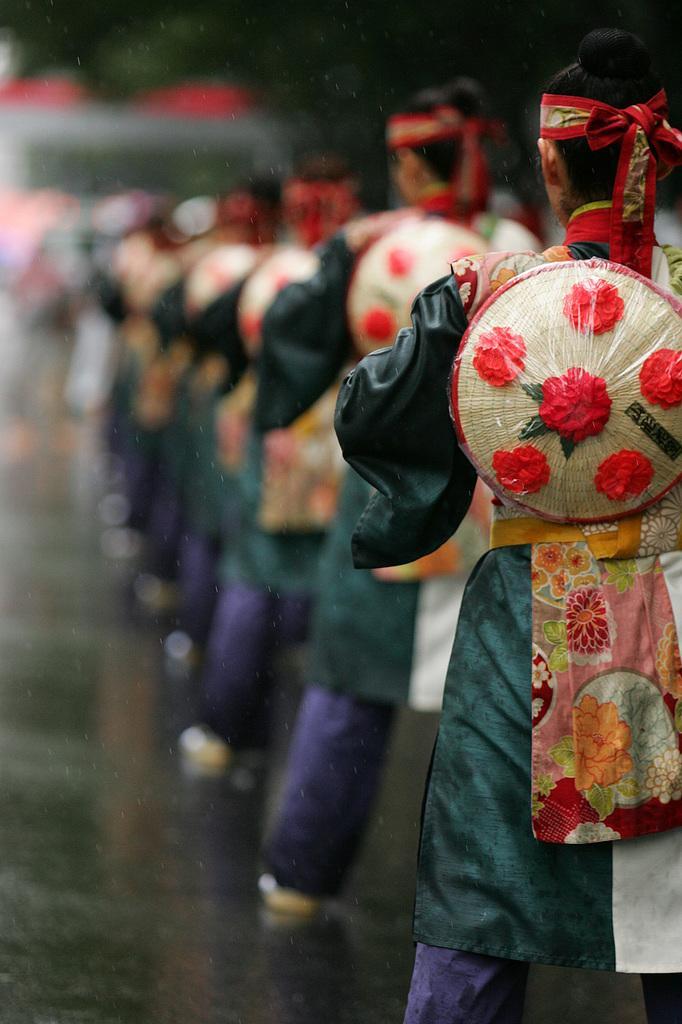Can you describe this image briefly? In this picture I can see there are a few people standing and they are wearing costumes, the backdrop is blurred. 